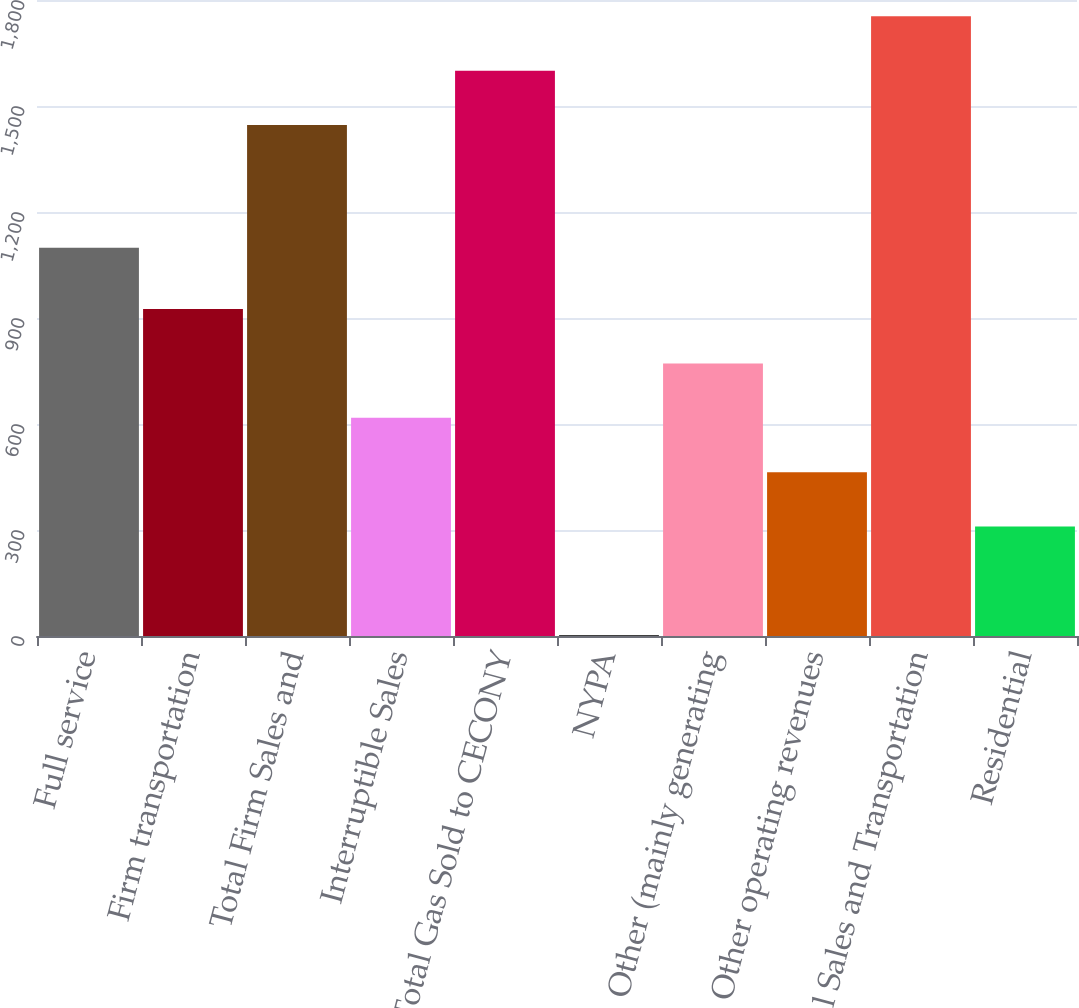<chart> <loc_0><loc_0><loc_500><loc_500><bar_chart><fcel>Full service<fcel>Firm transportation<fcel>Total Firm Sales and<fcel>Interruptible Sales<fcel>Total Gas Sold to CECONY<fcel>NYPA<fcel>Other (mainly generating<fcel>Other operating revenues<fcel>Total Sales and Transportation<fcel>Residential<nl><fcel>1099<fcel>925.4<fcel>1446<fcel>617.6<fcel>1599.9<fcel>2<fcel>771.5<fcel>463.7<fcel>1753.8<fcel>309.8<nl></chart> 